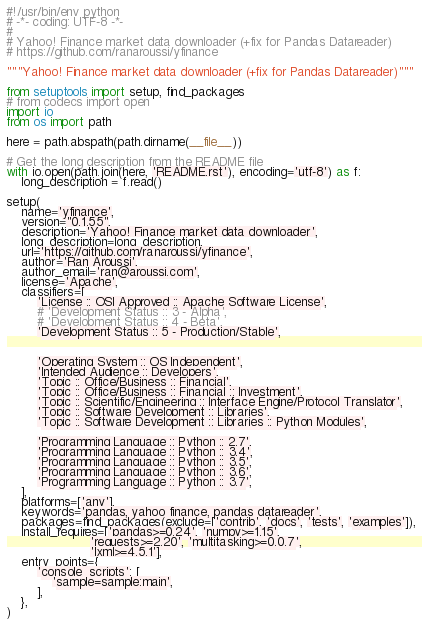<code> <loc_0><loc_0><loc_500><loc_500><_Python_>#!/usr/bin/env python
# -*- coding: UTF-8 -*-
#
# Yahoo! Finance market data downloader (+fix for Pandas Datareader)
# https://github.com/ranaroussi/yfinance

"""Yahoo! Finance market data downloader (+fix for Pandas Datareader)"""

from setuptools import setup, find_packages
# from codecs import open
import io
from os import path

here = path.abspath(path.dirname(__file__))

# Get the long description from the README file
with io.open(path.join(here, 'README.rst'), encoding='utf-8') as f:
    long_description = f.read()

setup(
    name='yfinance',
    version="0.1.55",
    description='Yahoo! Finance market data downloader',
    long_description=long_description,
    url='https://github.com/ranaroussi/yfinance',
    author='Ran Aroussi',
    author_email='ran@aroussi.com',
    license='Apache',
    classifiers=[
        'License :: OSI Approved :: Apache Software License',
        # 'Development Status :: 3 - Alpha',
        # 'Development Status :: 4 - Beta',
        'Development Status :: 5 - Production/Stable',


        'Operating System :: OS Independent',
        'Intended Audience :: Developers',
        'Topic :: Office/Business :: Financial',
        'Topic :: Office/Business :: Financial :: Investment',
        'Topic :: Scientific/Engineering :: Interface Engine/Protocol Translator',
        'Topic :: Software Development :: Libraries',
        'Topic :: Software Development :: Libraries :: Python Modules',

        'Programming Language :: Python :: 2.7',
        'Programming Language :: Python :: 3.4',
        'Programming Language :: Python :: 3.5',
        'Programming Language :: Python :: 3.6',
        'Programming Language :: Python :: 3.7',
    ],
    platforms=['any'],
    keywords='pandas, yahoo finance, pandas datareader',
    packages=find_packages(exclude=['contrib', 'docs', 'tests', 'examples']),
    install_requires=['pandas>=0.24', 'numpy>=1.15',
                      'requests>=2.20', 'multitasking>=0.0.7',
                      'lxml>=4.5.1'],
    entry_points={
        'console_scripts': [
            'sample=sample:main',
        ],
    },
)
</code> 